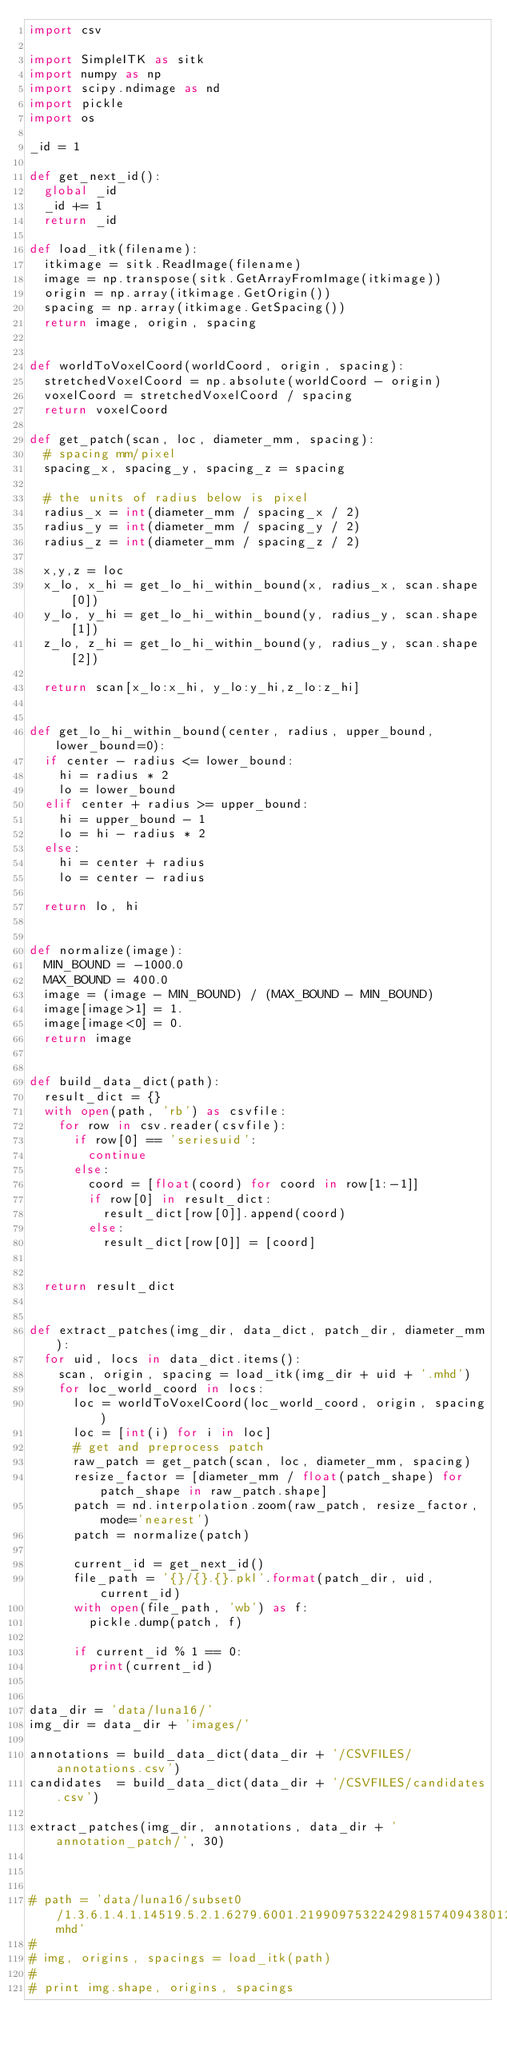<code> <loc_0><loc_0><loc_500><loc_500><_Python_>import csv

import SimpleITK as sitk
import numpy as np
import scipy.ndimage as nd
import pickle
import os

_id = 1

def get_next_id():
  global _id
  _id += 1
  return _id

def load_itk(filename):
  itkimage = sitk.ReadImage(filename)
  image = np.transpose(sitk.GetArrayFromImage(itkimage))
  origin = np.array(itkimage.GetOrigin())
  spacing = np.array(itkimage.GetSpacing())
  return image, origin, spacing


def worldToVoxelCoord(worldCoord, origin, spacing):
  stretchedVoxelCoord = np.absolute(worldCoord - origin)
  voxelCoord = stretchedVoxelCoord / spacing
  return voxelCoord

def get_patch(scan, loc, diameter_mm, spacing):
  # spacing mm/pixel
  spacing_x, spacing_y, spacing_z = spacing

  # the units of radius below is pixel
  radius_x = int(diameter_mm / spacing_x / 2)
  radius_y = int(diameter_mm / spacing_y / 2)
  radius_z = int(diameter_mm / spacing_z / 2)

  x,y,z = loc
  x_lo, x_hi = get_lo_hi_within_bound(x, radius_x, scan.shape[0])
  y_lo, y_hi = get_lo_hi_within_bound(y, radius_y, scan.shape[1])
  z_lo, z_hi = get_lo_hi_within_bound(y, radius_y, scan.shape[2])

  return scan[x_lo:x_hi, y_lo:y_hi,z_lo:z_hi]


def get_lo_hi_within_bound(center, radius, upper_bound, lower_bound=0):
  if center - radius <= lower_bound:
    hi = radius * 2
    lo = lower_bound
  elif center + radius >= upper_bound:
    hi = upper_bound - 1
    lo = hi - radius * 2
  else:
    hi = center + radius
    lo = center - radius

  return lo, hi


def normalize(image):
  MIN_BOUND = -1000.0
  MAX_BOUND = 400.0
  image = (image - MIN_BOUND) / (MAX_BOUND - MIN_BOUND)
  image[image>1] = 1.
  image[image<0] = 0.
  return image


def build_data_dict(path):
  result_dict = {}
  with open(path, 'rb') as csvfile:
    for row in csv.reader(csvfile):
      if row[0] == 'seriesuid':
        continue
      else:
        coord = [float(coord) for coord in row[1:-1]]
        if row[0] in result_dict:
          result_dict[row[0]].append(coord)
        else:
          result_dict[row[0]] = [coord]


  return result_dict


def extract_patches(img_dir, data_dict, patch_dir, diameter_mm):
  for uid, locs in data_dict.items():
    scan, origin, spacing = load_itk(img_dir + uid + '.mhd')
    for loc_world_coord in locs:
      loc = worldToVoxelCoord(loc_world_coord, origin, spacing)
      loc = [int(i) for i in loc]
      # get and preprocess patch
      raw_patch = get_patch(scan, loc, diameter_mm, spacing)
      resize_factor = [diameter_mm / float(patch_shape) for patch_shape in raw_patch.shape]
      patch = nd.interpolation.zoom(raw_patch, resize_factor, mode='nearest')
      patch = normalize(patch)

      current_id = get_next_id()
      file_path = '{}/{}.{}.pkl'.format(patch_dir, uid, current_id)
      with open(file_path, 'wb') as f:
        pickle.dump(patch, f)

      if current_id % 1 == 0:
        print(current_id)


data_dir = 'data/luna16/'
img_dir = data_dir + 'images/'

annotations = build_data_dict(data_dir + '/CSVFILES/annotations.csv')
candidates  = build_data_dict(data_dir + '/CSVFILES/candidates.csv')

extract_patches(img_dir, annotations, data_dir + 'annotation_patch/', 30)



# path = 'data/luna16/subset0/1.3.6.1.4.1.14519.5.2.1.6279.6001.219909753224298157409438012179.mhd'
#
# img, origins, spacings = load_itk(path)
#
# print img.shape, origins, spacings
</code> 